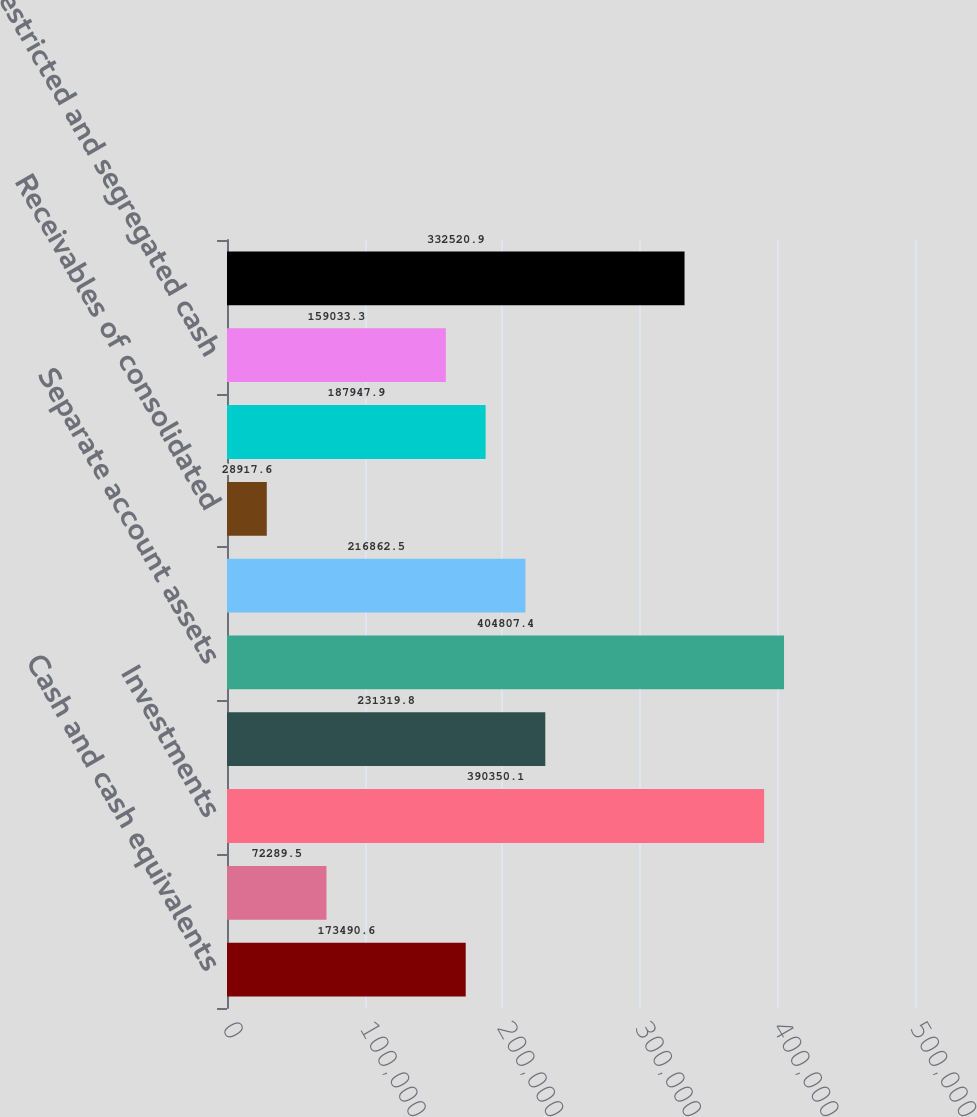<chart> <loc_0><loc_0><loc_500><loc_500><bar_chart><fcel>Cash and cash equivalents<fcel>Cash of consolidated<fcel>Investments<fcel>Investments of consolidated<fcel>Separate account assets<fcel>Receivables<fcel>Receivables of consolidated<fcel>Deferred acquisition costs<fcel>Restricted and segregated cash<fcel>Other assets<nl><fcel>173491<fcel>72289.5<fcel>390350<fcel>231320<fcel>404807<fcel>216862<fcel>28917.6<fcel>187948<fcel>159033<fcel>332521<nl></chart> 